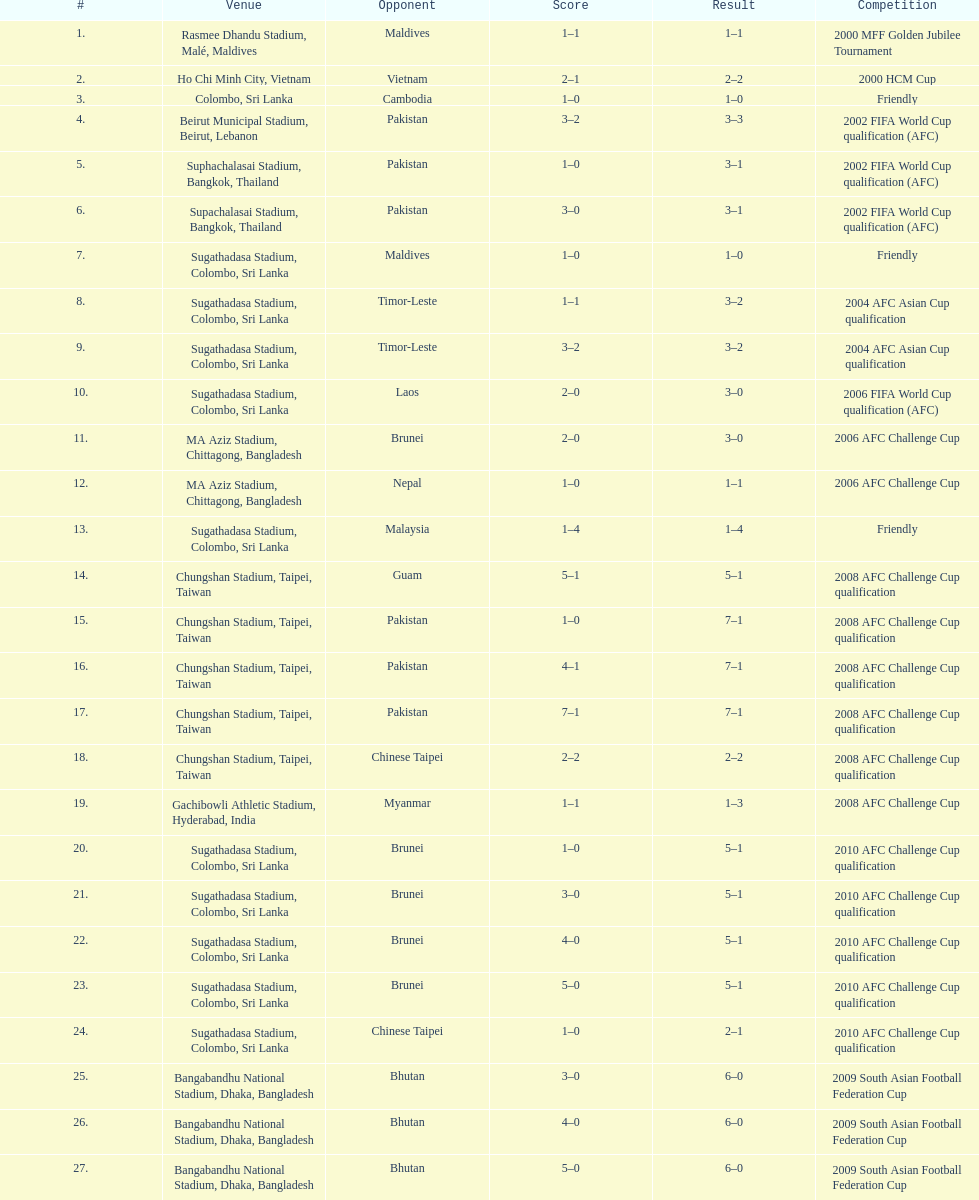In which month were there more competitions, april or december? April. 